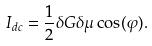Convert formula to latex. <formula><loc_0><loc_0><loc_500><loc_500>I _ { d c } = \frac { 1 } { 2 } \delta G \delta \mu \cos ( \varphi ) .</formula> 